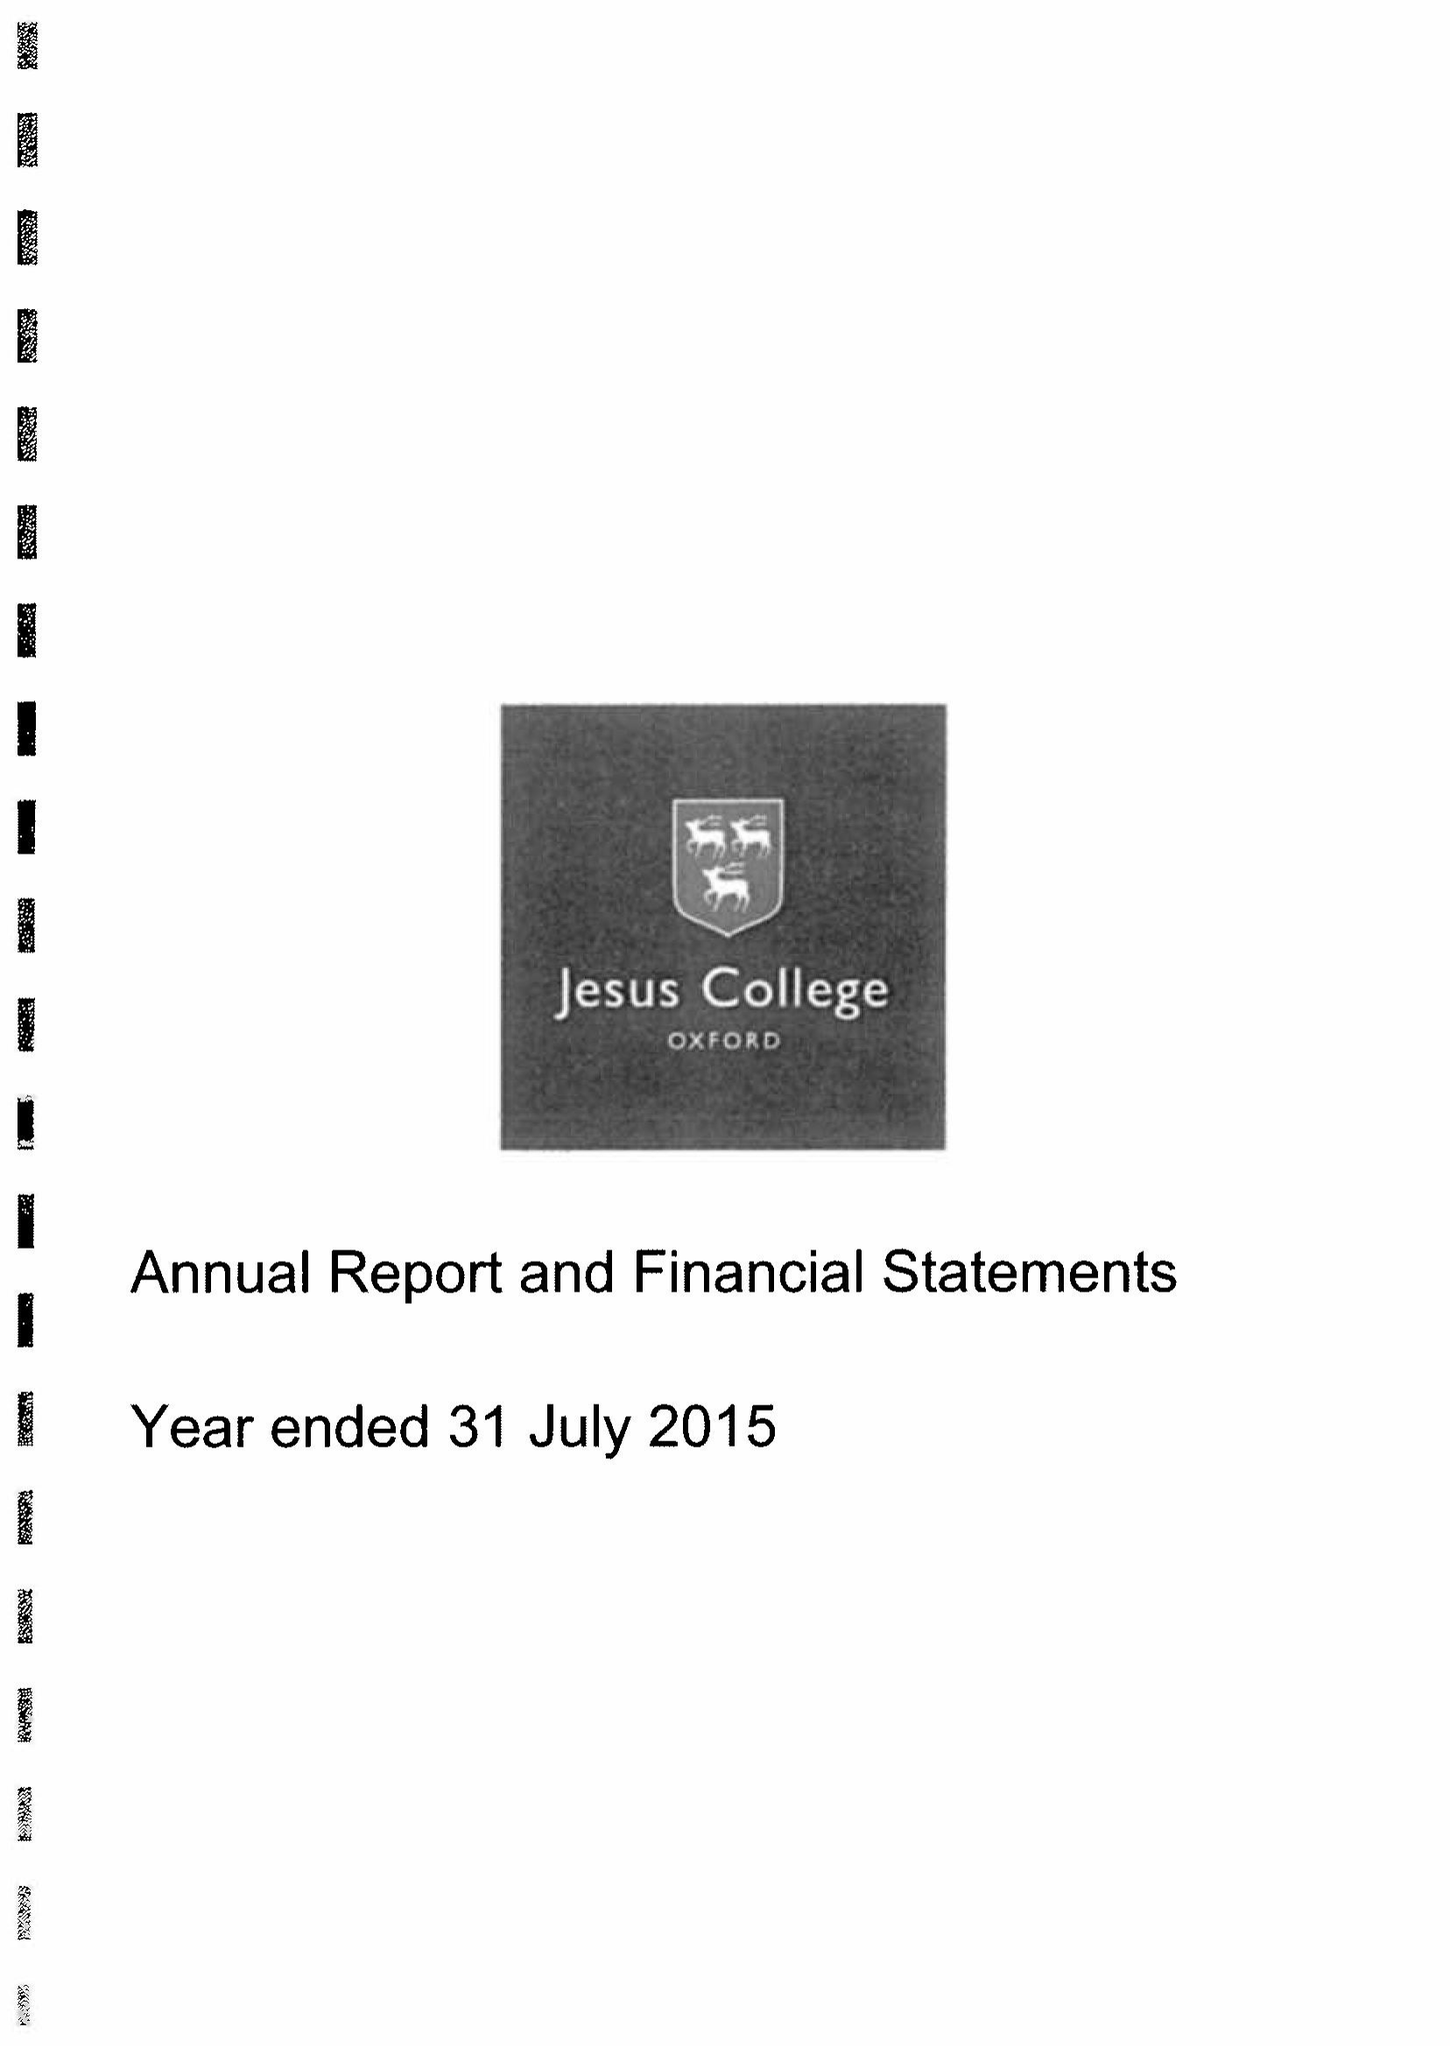What is the value for the charity_number?
Answer the question using a single word or phrase. 1137435 